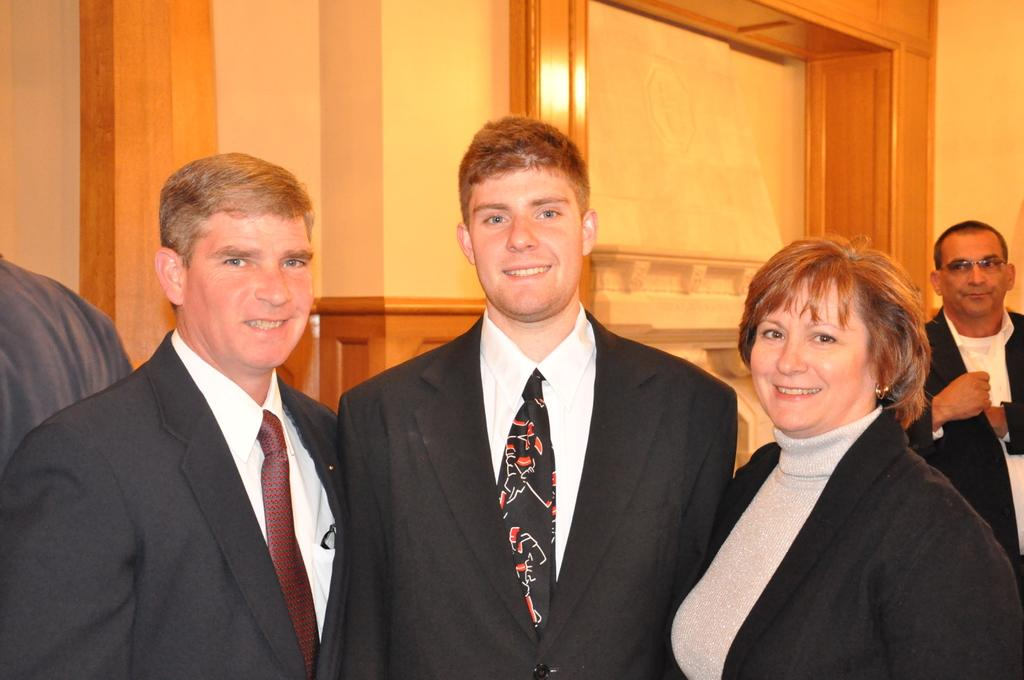What are the people in the image doing? The people in the image are standing and smiling. What can be seen in the background of the image? There is a wall in the background of the image. What type of error can be seen in the image? There is no error present in the image; it features people standing and smiling with a wall in the background. 